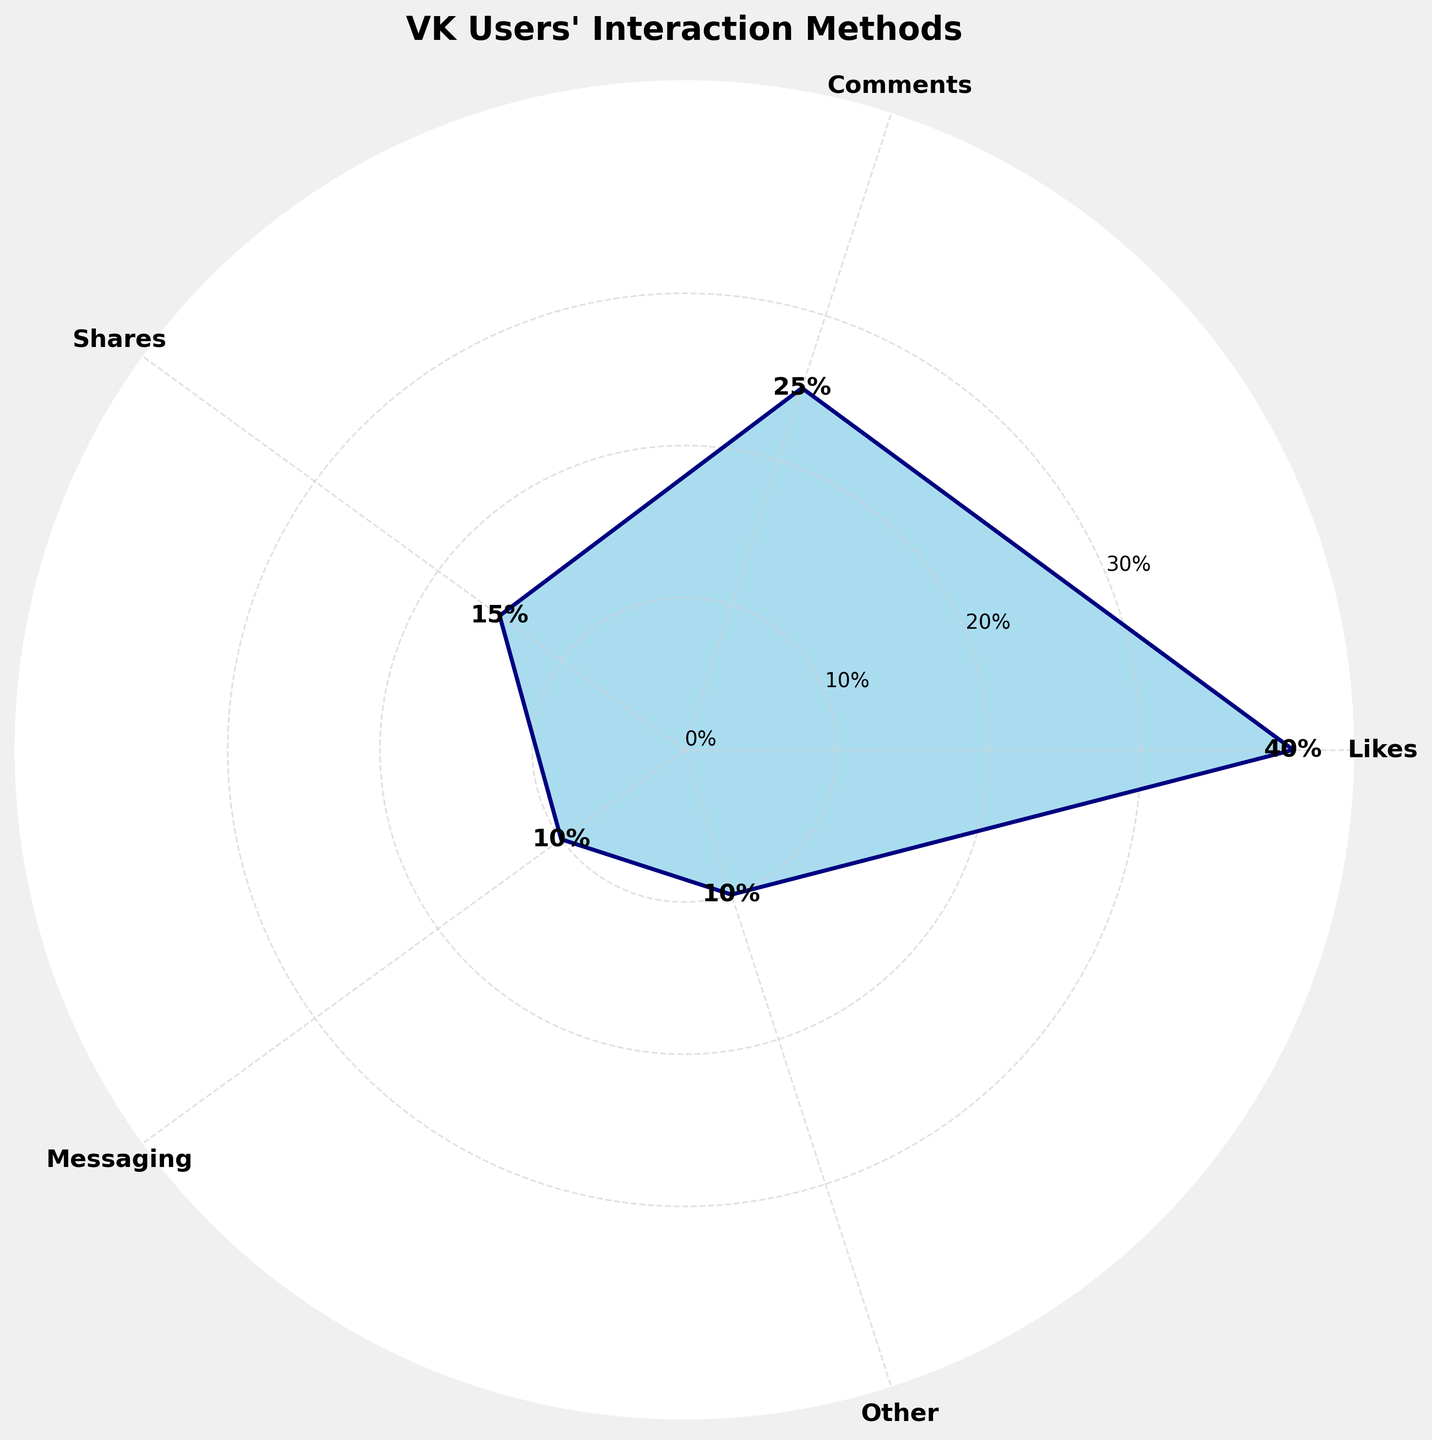What is the title of the polar area chart? The title can be found at the top of the chart. It is usually in a larger and bolder font than other text in the figure.
Answer: VK Users' Interaction Methods How many interaction methods are represented in the chart? Count the number of different labels displayed around the perimeter of the polar area chart.
Answer: 5 Which interaction method has the highest proportion? Identify the segment with the largest area or the highest numerical value indicated near it.
Answer: Likes What is the proportion of VK users using the Messaging interaction method? Look for the label 'Messaging' and read the associated value percentage in the chart.
Answer: 10% What is the sum of the proportions of the top two interaction methods? Identify the top two largest segments (Likes and Comments) and add their percentages together: 40% + 25%.
Answer: 65% Which interaction method has a smaller proportion than Shares but larger than Other? Compare the proportions of each interaction method, focusing on those for Shares (15%) and Other (10%).
Answer: Messaging What is the difference between the highest and lowest interaction method proportions? Subtract the smallest proportion (Other = 10%) from the largest proportion (Likes = 40%).
Answer: 30% Are Shares and Comments' combined proportions equal to or greater than half the total (50%)? Add the proportions of Shares (15%) and Comments (25%) and compare with 50%.
Answer: Equal How does the proportion of VK users who engage via Comments compare to those who use Messaging? Compare the percentages given for Comments (25%) and Messaging (10%) directly.
Answer: Comments > Messaging What is the average proportion across all interaction methods? Sum all the proportions (40% + 25% + 15% + 10% + 10% = 100%) and divide by the number of interaction methods (5).
Answer: 20% 